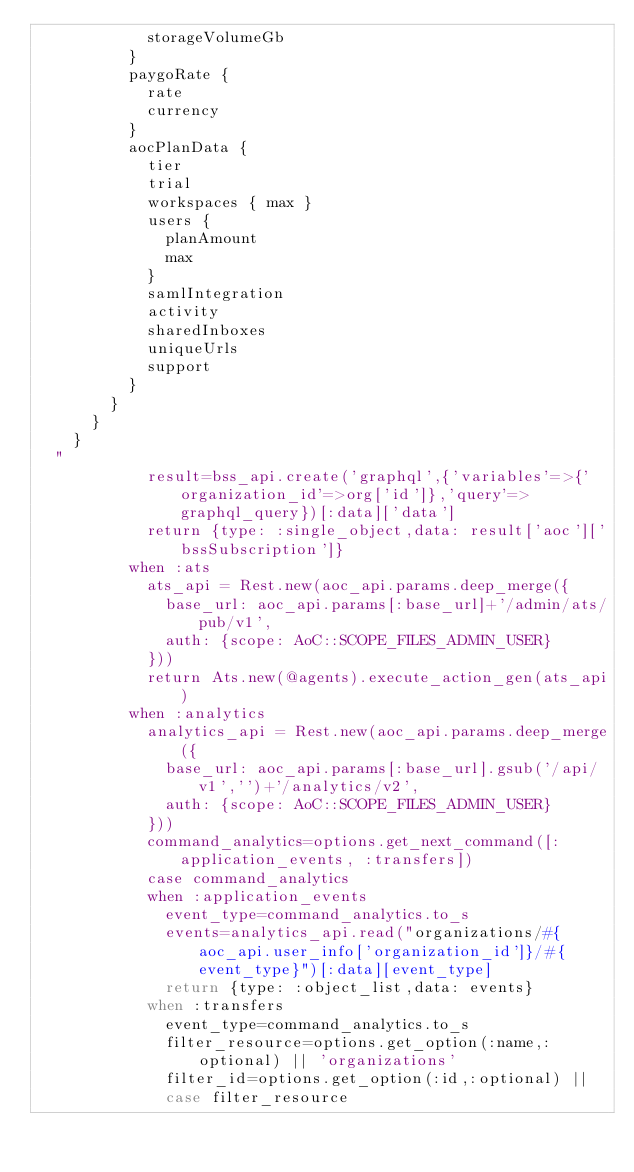<code> <loc_0><loc_0><loc_500><loc_500><_Ruby_>            storageVolumeGb
          }
          paygoRate {
            rate
            currency
          }
          aocPlanData {
            tier
            trial
            workspaces { max }
            users {
              planAmount
              max
            }
            samlIntegration
            activity
            sharedInboxes
            uniqueUrls
            support
          }
        }
      }
    }
  "
            result=bss_api.create('graphql',{'variables'=>{'organization_id'=>org['id']},'query'=>graphql_query})[:data]['data']
            return {type: :single_object,data: result['aoc']['bssSubscription']}
          when :ats
            ats_api = Rest.new(aoc_api.params.deep_merge({
              base_url: aoc_api.params[:base_url]+'/admin/ats/pub/v1',
              auth: {scope: AoC::SCOPE_FILES_ADMIN_USER}
            }))
            return Ats.new(@agents).execute_action_gen(ats_api)
          when :analytics
            analytics_api = Rest.new(aoc_api.params.deep_merge({
              base_url: aoc_api.params[:base_url].gsub('/api/v1','')+'/analytics/v2',
              auth: {scope: AoC::SCOPE_FILES_ADMIN_USER}
            }))
            command_analytics=options.get_next_command([:application_events, :transfers])
            case command_analytics
            when :application_events
              event_type=command_analytics.to_s
              events=analytics_api.read("organizations/#{aoc_api.user_info['organization_id']}/#{event_type}")[:data][event_type]
              return {type: :object_list,data: events}
            when :transfers
              event_type=command_analytics.to_s
              filter_resource=options.get_option(:name,:optional) || 'organizations'
              filter_id=options.get_option(:id,:optional) ||
              case filter_resource</code> 